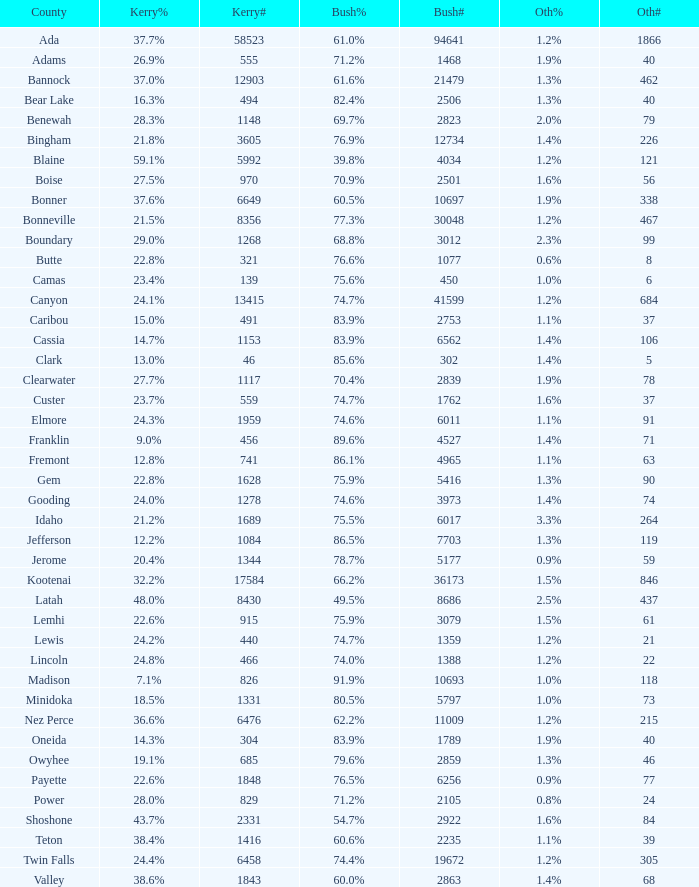What's percentage voted for Busg in the county where Kerry got 37.6%? 60.5%. 